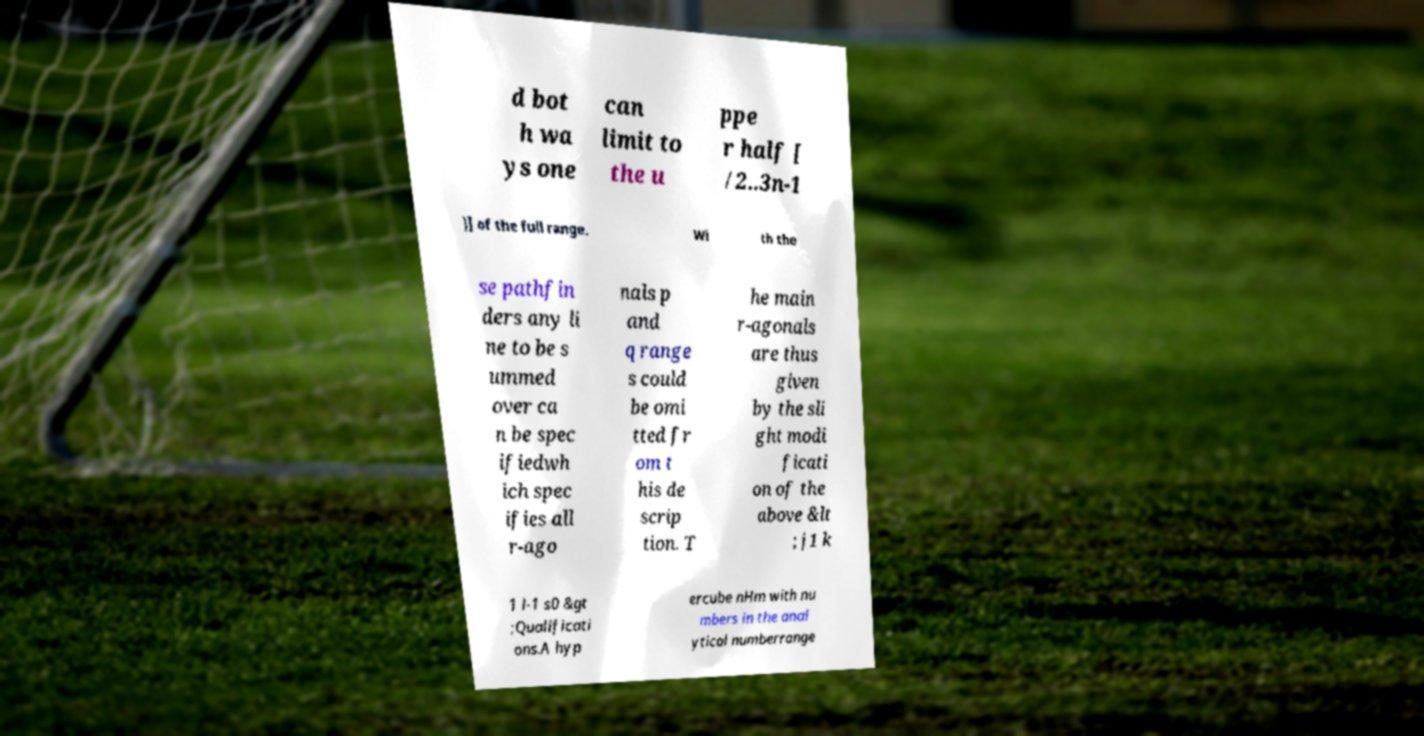I need the written content from this picture converted into text. Can you do that? d bot h wa ys one can limit to the u ppe r half [ /2..3n-1 )] of the full range. Wi th the se pathfin ders any li ne to be s ummed over ca n be spec ifiedwh ich spec ifies all r-ago nals p and q range s could be omi tted fr om t his de scrip tion. T he main r-agonals are thus given by the sli ght modi ficati on of the above &lt ; j1 k 1 l-1 s0 &gt ;Qualificati ons.A hyp ercube nHm with nu mbers in the anal ytical numberrange 